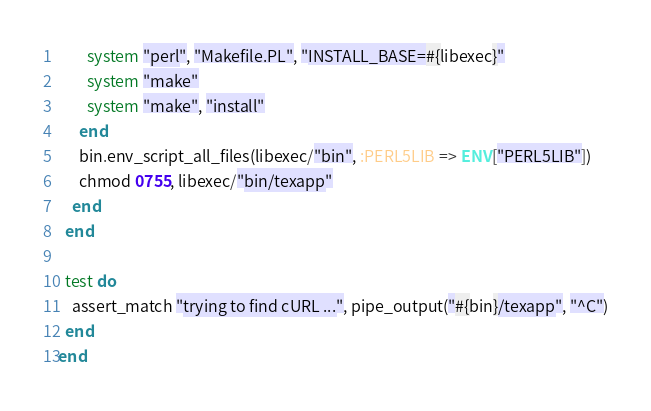Convert code to text. <code><loc_0><loc_0><loc_500><loc_500><_Ruby_>        system "perl", "Makefile.PL", "INSTALL_BASE=#{libexec}"
        system "make"
        system "make", "install"
      end
      bin.env_script_all_files(libexec/"bin", :PERL5LIB => ENV["PERL5LIB"])
      chmod 0755, libexec/"bin/texapp"
    end
  end

  test do
    assert_match "trying to find cURL ...", pipe_output("#{bin}/texapp", "^C")
  end
end
</code> 